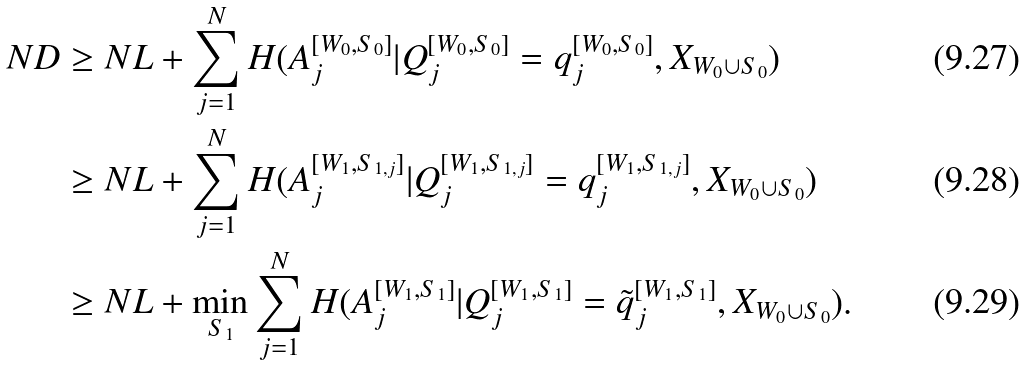<formula> <loc_0><loc_0><loc_500><loc_500>N D & \geq N L + \sum _ { j = 1 } ^ { N } H ( A _ { j } ^ { [ W _ { 0 } , S _ { 0 } ] } | Q _ { j } ^ { [ W _ { 0 } , S _ { 0 } ] } = q _ { j } ^ { [ W _ { 0 } , S _ { 0 } ] } , X _ { W _ { 0 } \cup S _ { 0 } } ) \\ & \geq N L + \sum _ { j = 1 } ^ { N } H ( A _ { j } ^ { [ W _ { 1 } , S _ { 1 , j } ] } | Q _ { j } ^ { [ W _ { 1 } , S _ { 1 , j } ] } = q _ { j } ^ { [ W _ { 1 } , S _ { 1 , j } ] } , X _ { W _ { 0 } \cup S _ { 0 } } ) \\ & \geq N L + \min _ { S _ { 1 } } \sum _ { j = 1 } ^ { N } H ( A _ { j } ^ { [ W _ { 1 } , S _ { 1 } ] } | Q _ { j } ^ { [ W _ { 1 } , S _ { 1 } ] } = \tilde { q } _ { j } ^ { [ W _ { 1 } , S _ { 1 } ] } , X _ { W _ { 0 } \cup S _ { 0 } } ) .</formula> 